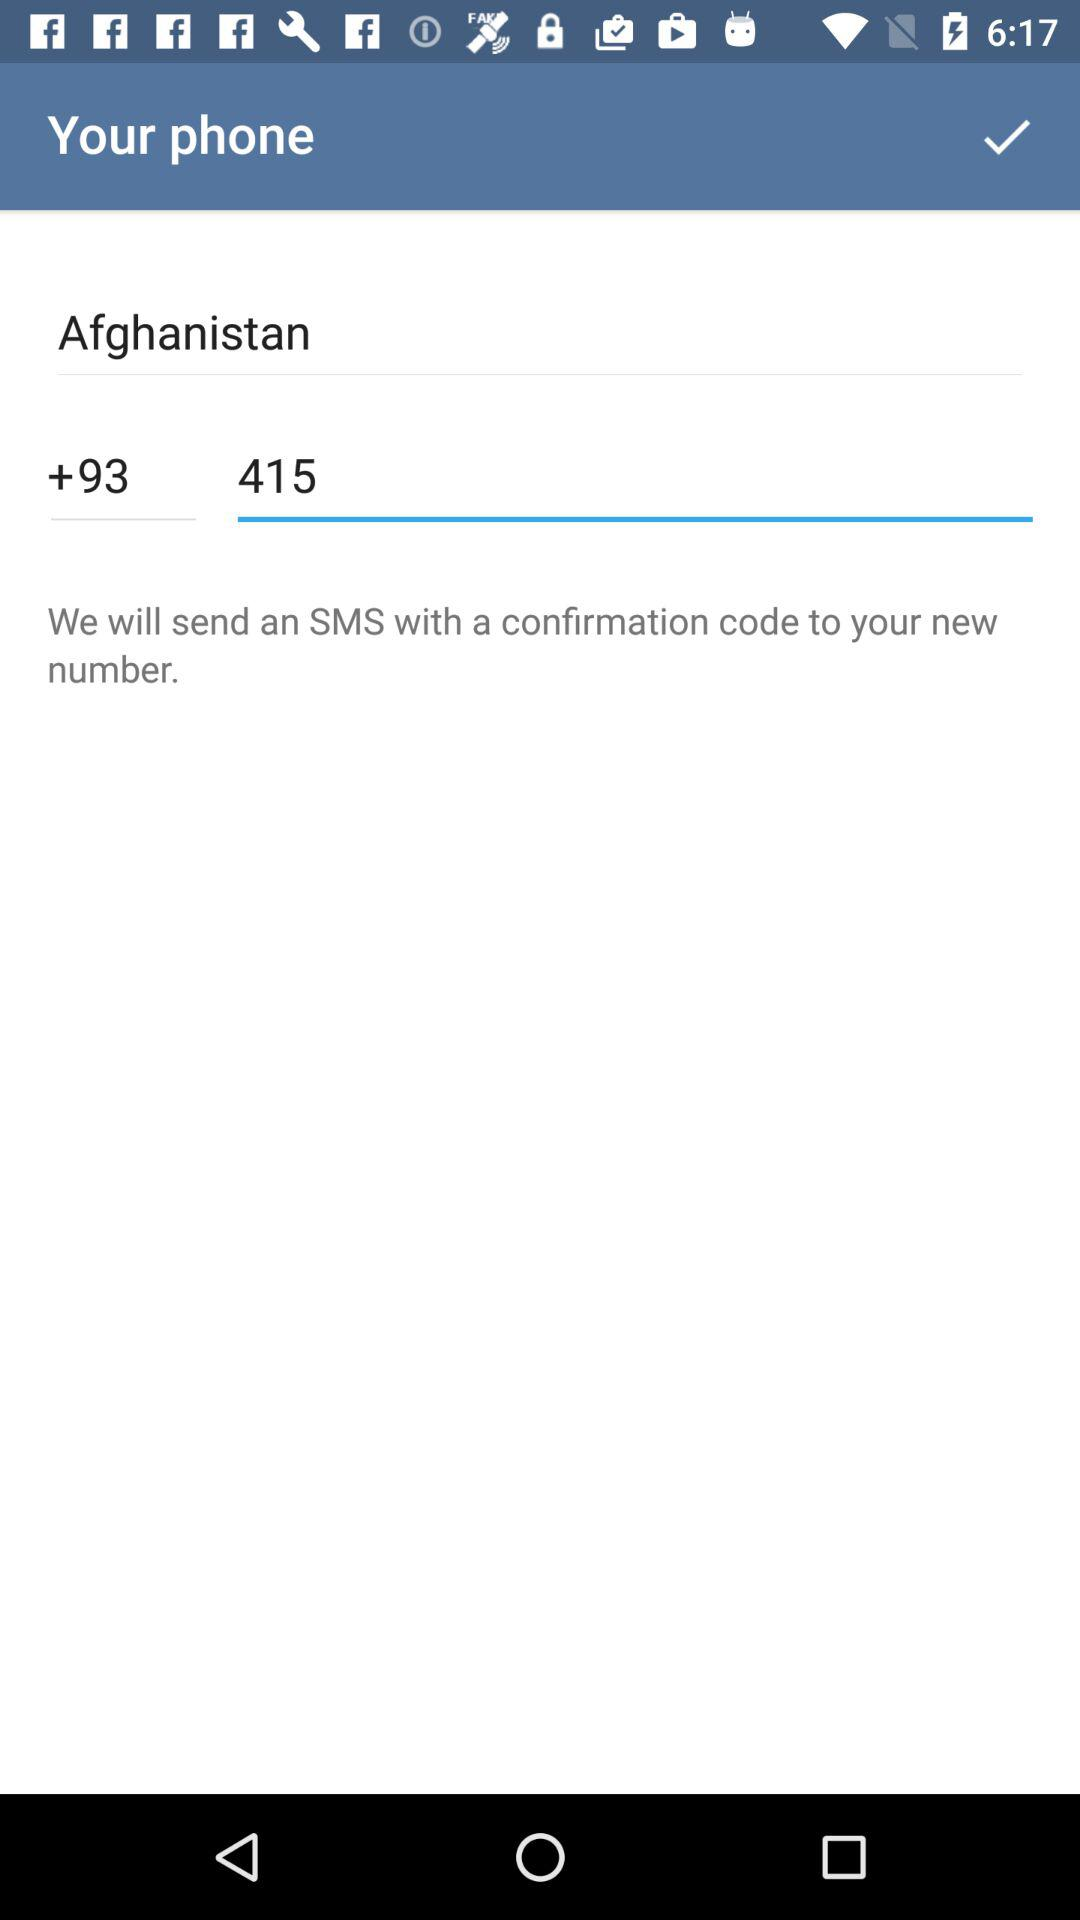Which country is selected? The selected country is Afghanistan. 